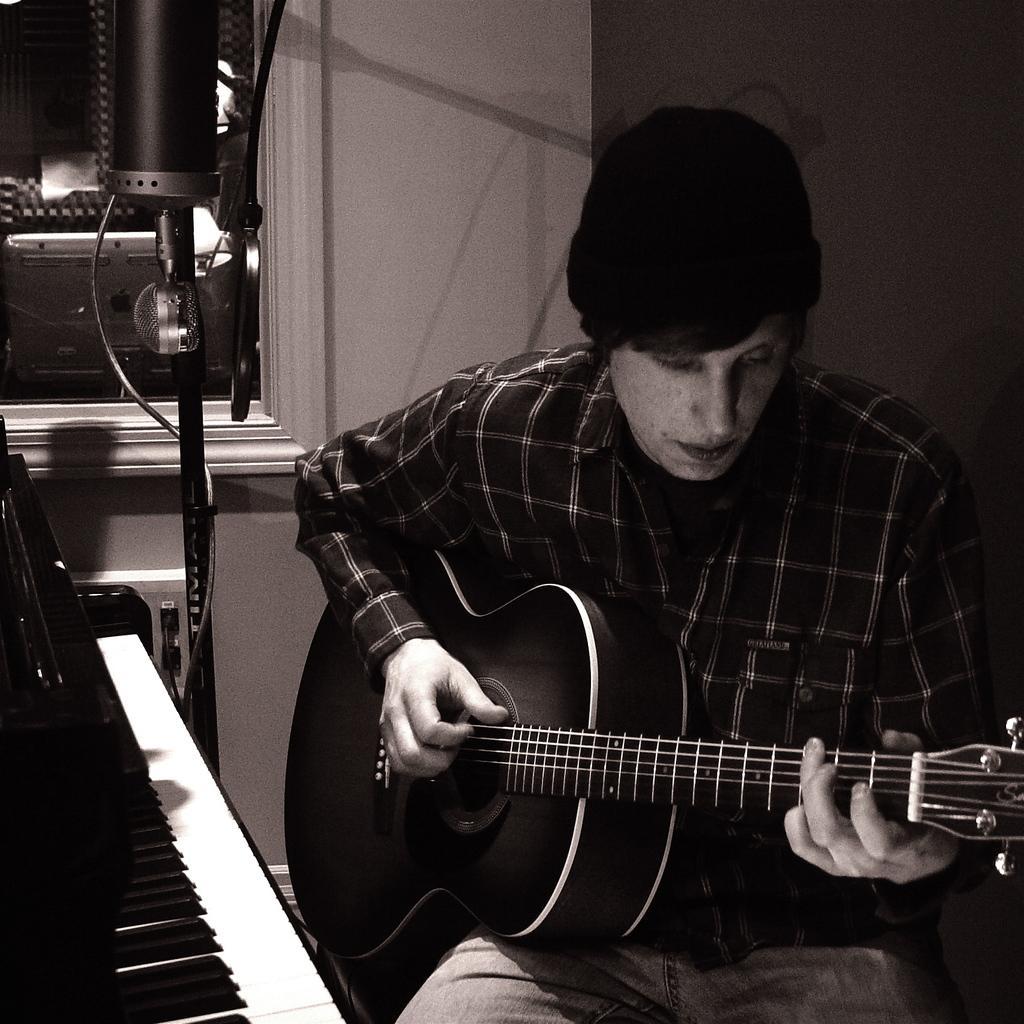Can you describe this image briefly? In this image I can see a person holding the guitar. To the left there is a piano. In the background there is a window. 